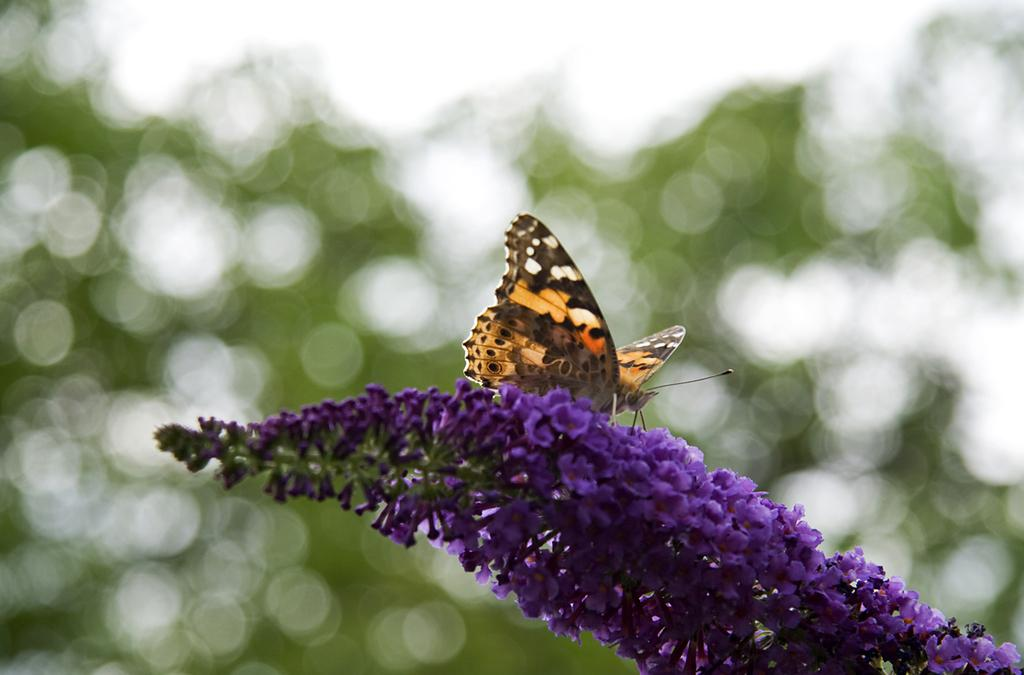What type of flora is present in the image? There are flowers in the image. What color are the flowers? The flowers are violet in color. Are there any other living organisms present in the image? Yes, there is a butterfly on the flowers. How would you describe the background of the image? The background of the image is blurred. What type of chalk is being used to draw on the wall in the image? There is no chalk or wall present in the image; it features flowers and a butterfly. 